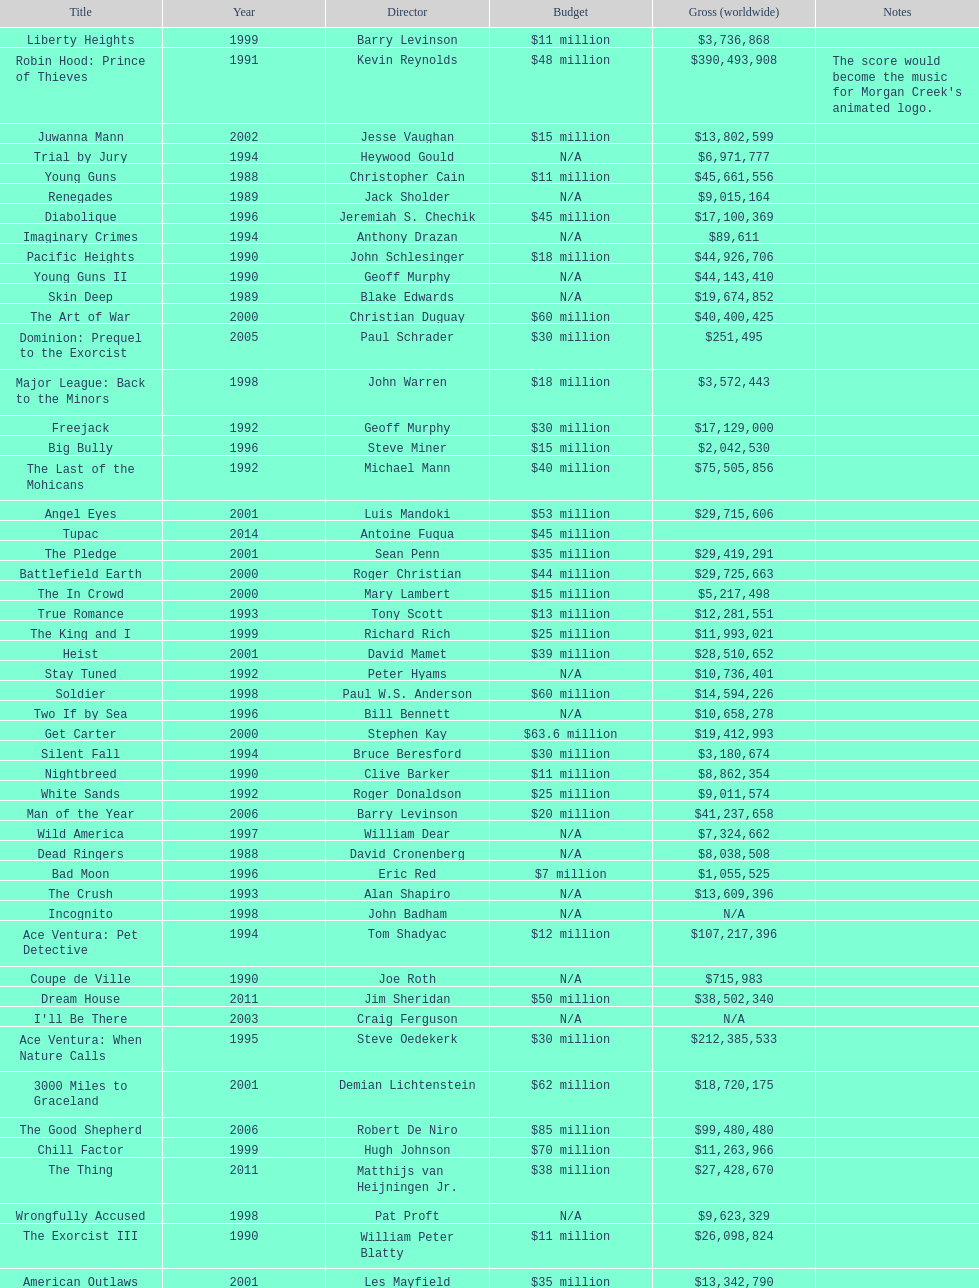What is the number of films directed by david s. ward? 2. Can you parse all the data within this table? {'header': ['Title', 'Year', 'Director', 'Budget', 'Gross (worldwide)', 'Notes'], 'rows': [['Liberty Heights', '1999', 'Barry Levinson', '$11 million', '$3,736,868', ''], ['Robin Hood: Prince of Thieves', '1991', 'Kevin Reynolds', '$48 million', '$390,493,908', "The score would become the music for Morgan Creek's animated logo."], ['Juwanna Mann', '2002', 'Jesse Vaughan', '$15 million', '$13,802,599', ''], ['Trial by Jury', '1994', 'Heywood Gould', 'N/A', '$6,971,777', ''], ['Young Guns', '1988', 'Christopher Cain', '$11 million', '$45,661,556', ''], ['Renegades', '1989', 'Jack Sholder', 'N/A', '$9,015,164', ''], ['Diabolique', '1996', 'Jeremiah S. Chechik', '$45 million', '$17,100,369', ''], ['Imaginary Crimes', '1994', 'Anthony Drazan', 'N/A', '$89,611', ''], ['Pacific Heights', '1990', 'John Schlesinger', '$18 million', '$44,926,706', ''], ['Young Guns II', '1990', 'Geoff Murphy', 'N/A', '$44,143,410', ''], ['Skin Deep', '1989', 'Blake Edwards', 'N/A', '$19,674,852', ''], ['The Art of War', '2000', 'Christian Duguay', '$60 million', '$40,400,425', ''], ['Dominion: Prequel to the Exorcist', '2005', 'Paul Schrader', '$30 million', '$251,495', ''], ['Major League: Back to the Minors', '1998', 'John Warren', '$18 million', '$3,572,443', ''], ['Freejack', '1992', 'Geoff Murphy', '$30 million', '$17,129,000', ''], ['Big Bully', '1996', 'Steve Miner', '$15 million', '$2,042,530', ''], ['The Last of the Mohicans', '1992', 'Michael Mann', '$40 million', '$75,505,856', ''], ['Angel Eyes', '2001', 'Luis Mandoki', '$53 million', '$29,715,606', ''], ['Tupac', '2014', 'Antoine Fuqua', '$45 million', '', ''], ['The Pledge', '2001', 'Sean Penn', '$35 million', '$29,419,291', ''], ['Battlefield Earth', '2000', 'Roger Christian', '$44 million', '$29,725,663', ''], ['The In Crowd', '2000', 'Mary Lambert', '$15 million', '$5,217,498', ''], ['True Romance', '1993', 'Tony Scott', '$13 million', '$12,281,551', ''], ['The King and I', '1999', 'Richard Rich', '$25 million', '$11,993,021', ''], ['Heist', '2001', 'David Mamet', '$39 million', '$28,510,652', ''], ['Stay Tuned', '1992', 'Peter Hyams', 'N/A', '$10,736,401', ''], ['Soldier', '1998', 'Paul W.S. Anderson', '$60 million', '$14,594,226', ''], ['Two If by Sea', '1996', 'Bill Bennett', 'N/A', '$10,658,278', ''], ['Get Carter', '2000', 'Stephen Kay', '$63.6 million', '$19,412,993', ''], ['Silent Fall', '1994', 'Bruce Beresford', '$30 million', '$3,180,674', ''], ['Nightbreed', '1990', 'Clive Barker', '$11 million', '$8,862,354', ''], ['White Sands', '1992', 'Roger Donaldson', '$25 million', '$9,011,574', ''], ['Man of the Year', '2006', 'Barry Levinson', '$20 million', '$41,237,658', ''], ['Wild America', '1997', 'William Dear', 'N/A', '$7,324,662', ''], ['Dead Ringers', '1988', 'David Cronenberg', 'N/A', '$8,038,508', ''], ['Bad Moon', '1996', 'Eric Red', '$7 million', '$1,055,525', ''], ['The Crush', '1993', 'Alan Shapiro', 'N/A', '$13,609,396', ''], ['Incognito', '1998', 'John Badham', 'N/A', 'N/A', ''], ['Ace Ventura: Pet Detective', '1994', 'Tom Shadyac', '$12 million', '$107,217,396', ''], ['Coupe de Ville', '1990', 'Joe Roth', 'N/A', '$715,983', ''], ['Dream House', '2011', 'Jim Sheridan', '$50 million', '$38,502,340', ''], ["I'll Be There", '2003', 'Craig Ferguson', 'N/A', 'N/A', ''], ['Ace Ventura: When Nature Calls', '1995', 'Steve Oedekerk', '$30 million', '$212,385,533', ''], ['3000 Miles to Graceland', '2001', 'Demian Lichtenstein', '$62 million', '$18,720,175', ''], ['The Good Shepherd', '2006', 'Robert De Niro', '$85 million', '$99,480,480', ''], ['Chill Factor', '1999', 'Hugh Johnson', '$70 million', '$11,263,966', ''], ['The Thing', '2011', 'Matthijs van Heijningen Jr.', '$38 million', '$27,428,670', ''], ['Wrongfully Accused', '1998', 'Pat Proft', 'N/A', '$9,623,329', ''], ['The Exorcist III', '1990', 'William Peter Blatty', '$11 million', '$26,098,824', ''], ['American Outlaws', '2001', 'Les Mayfield', '$35 million', '$13,342,790', ''], ['Exorcist: The Beginning', '2004', 'Renny Harlin', '$80 million', '$78,000,586', ''], ['Sydney White', '2007', 'Joe Nussbaum', 'N/A', '$13,620,075', ''], ['Major League', '1989', 'David S. Ward', '$11 million', '$49,797,148', ''], ['Major League II', '1994', 'David S. Ward', '$25 million', '$30,626,182', ''], ['Ace Ventura Jr: Pet Detective', '2009', 'David Mickey Evans', '$7.5 million', 'N/A', ''], ['Two for the Money', '2005', 'D. J. Caruso', '$25 million', '$30,526,509', ''], ['Georgia Rule', '2007', 'Garry Marshall', '$20 million', '$25,992,167', ''], ['Chasers', '1994', 'Dennis Hopper', '$15 million', '$1,596,687', ''], ['Enemies, a Love Story', '1989', 'Paul Mazursky', 'N/A', '$7,754,571', ''], ['The Whole Nine Yards', '2000', 'Jonathan Lynn', '$41.3 million', '$106,371,651', '']]} 